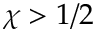Convert formula to latex. <formula><loc_0><loc_0><loc_500><loc_500>\chi > 1 / 2</formula> 